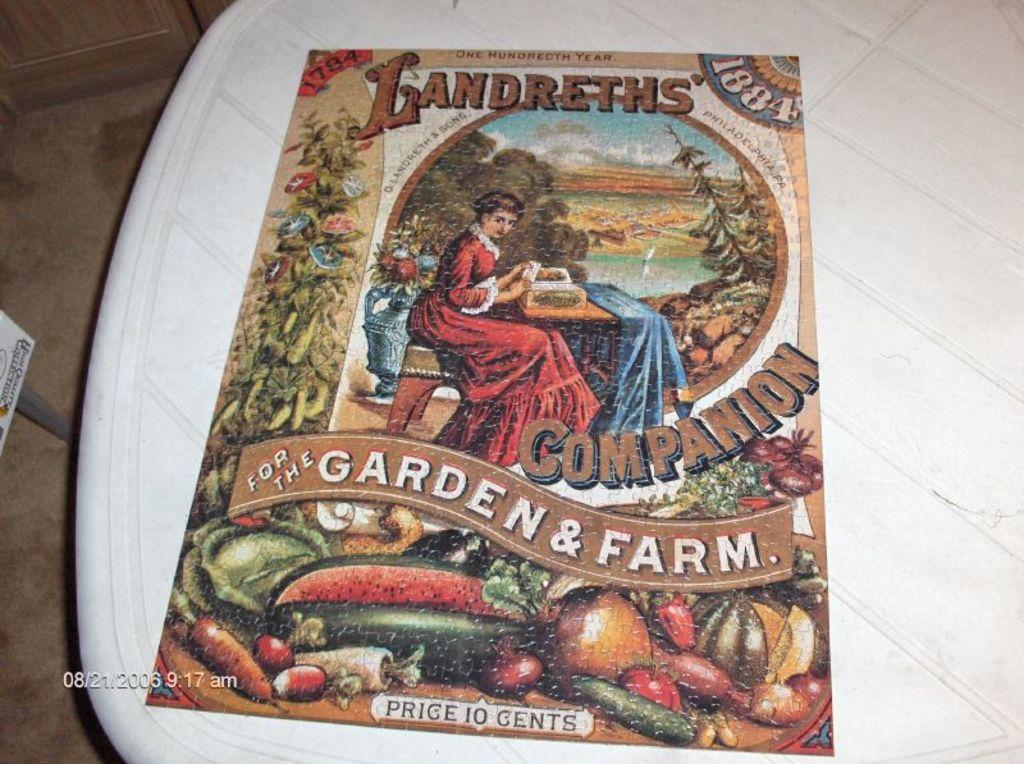<image>
Provide a brief description of the given image. A booklet titled "Landreths' Companion For The Garden & Farm" 